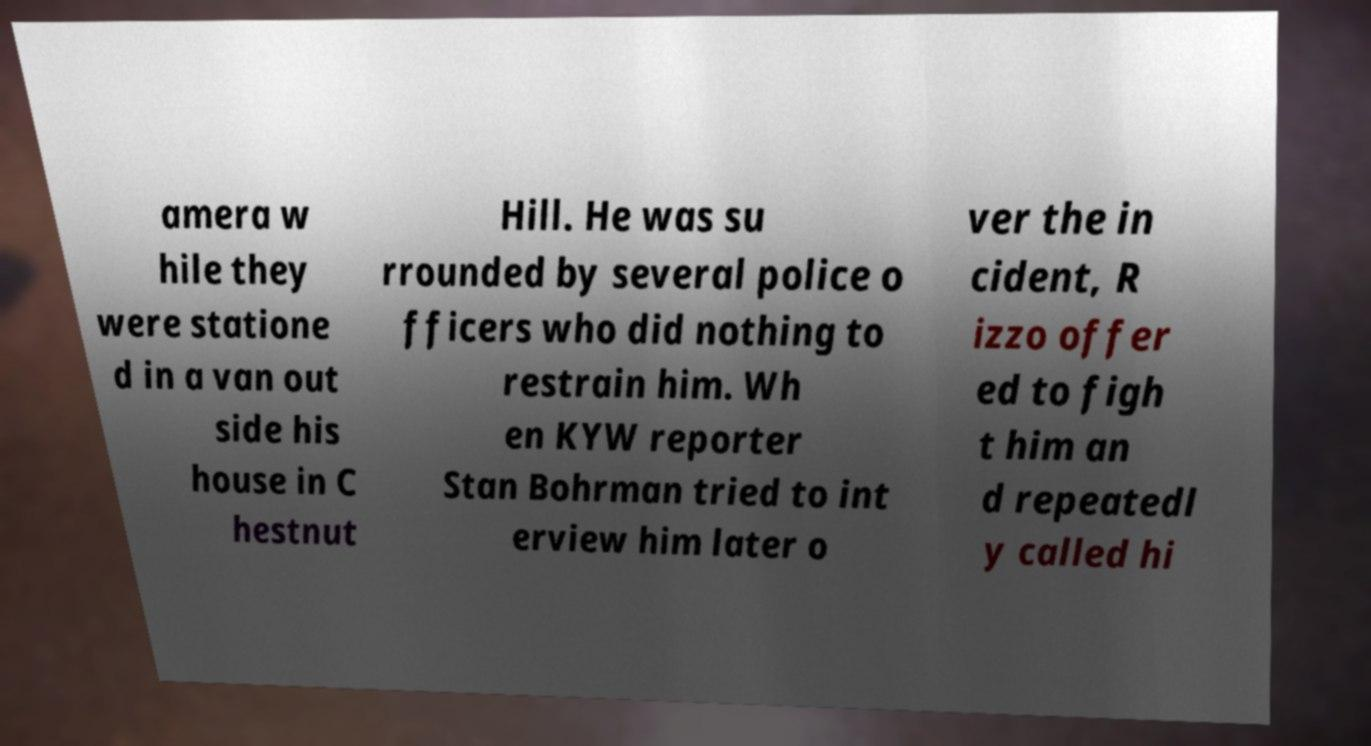Could you extract and type out the text from this image? amera w hile they were statione d in a van out side his house in C hestnut Hill. He was su rrounded by several police o fficers who did nothing to restrain him. Wh en KYW reporter Stan Bohrman tried to int erview him later o ver the in cident, R izzo offer ed to figh t him an d repeatedl y called hi 